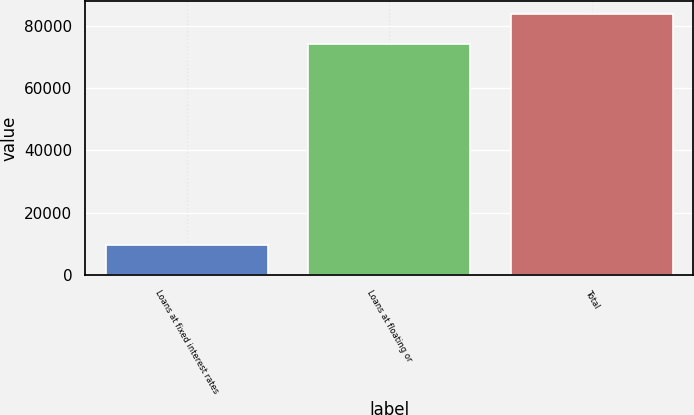Convert chart to OTSL. <chart><loc_0><loc_0><loc_500><loc_500><bar_chart><fcel>Loans at fixed interest rates<fcel>Loans at floating or<fcel>Total<nl><fcel>9858<fcel>73963<fcel>83821<nl></chart> 